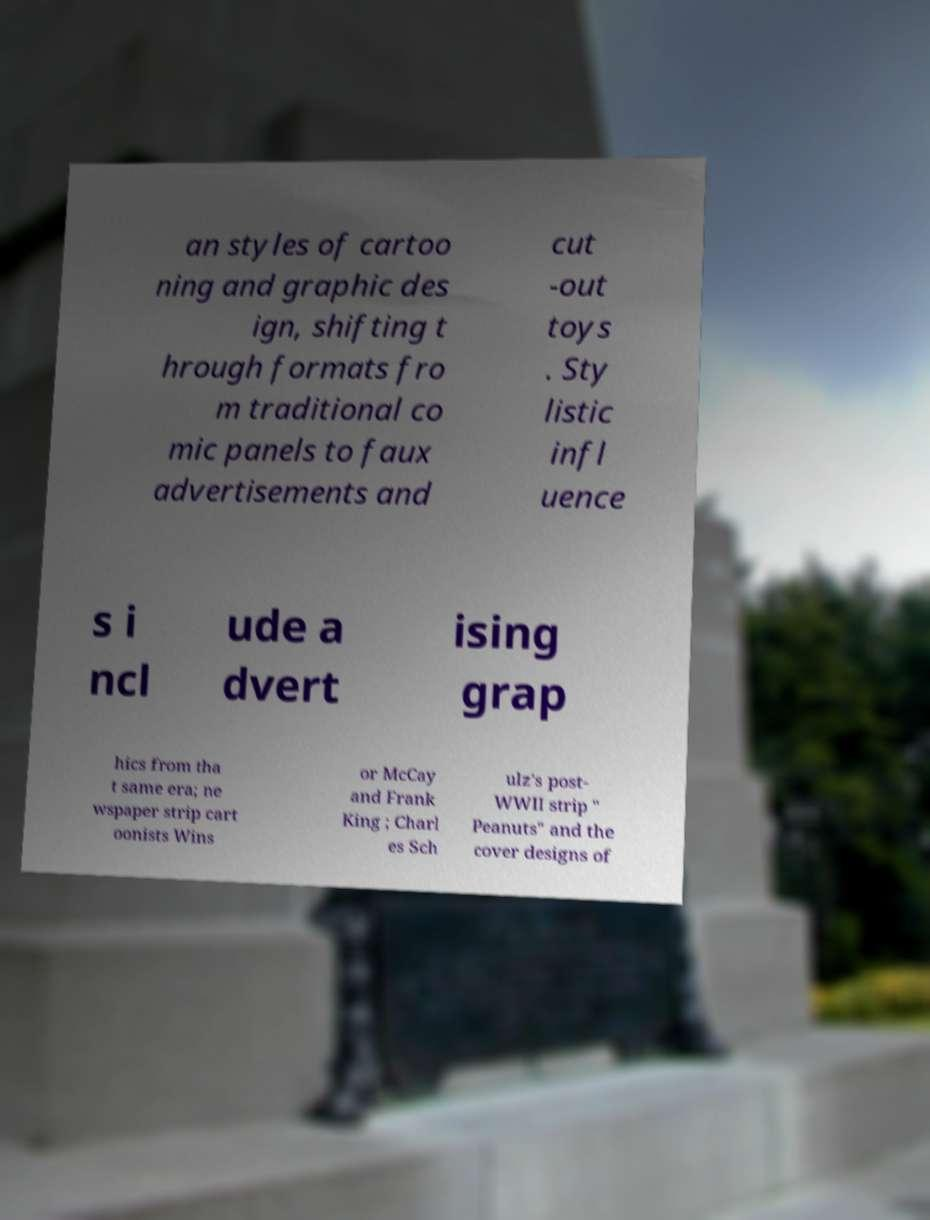I need the written content from this picture converted into text. Can you do that? an styles of cartoo ning and graphic des ign, shifting t hrough formats fro m traditional co mic panels to faux advertisements and cut -out toys . Sty listic infl uence s i ncl ude a dvert ising grap hics from tha t same era; ne wspaper strip cart oonists Wins or McCay and Frank King ; Charl es Sch ulz's post- WWII strip " Peanuts" and the cover designs of 